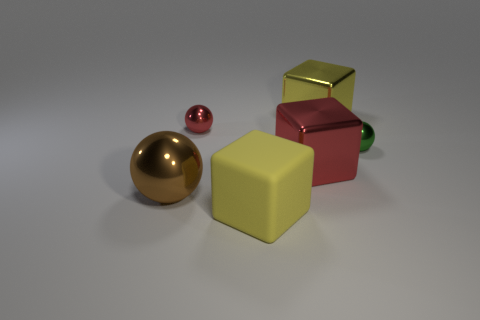Add 3 tiny purple cubes. How many objects exist? 9 Add 1 rubber things. How many rubber things are left? 2 Add 2 rubber things. How many rubber things exist? 3 Subtract 0 blue cylinders. How many objects are left? 6 Subtract all yellow things. Subtract all small red matte cylinders. How many objects are left? 4 